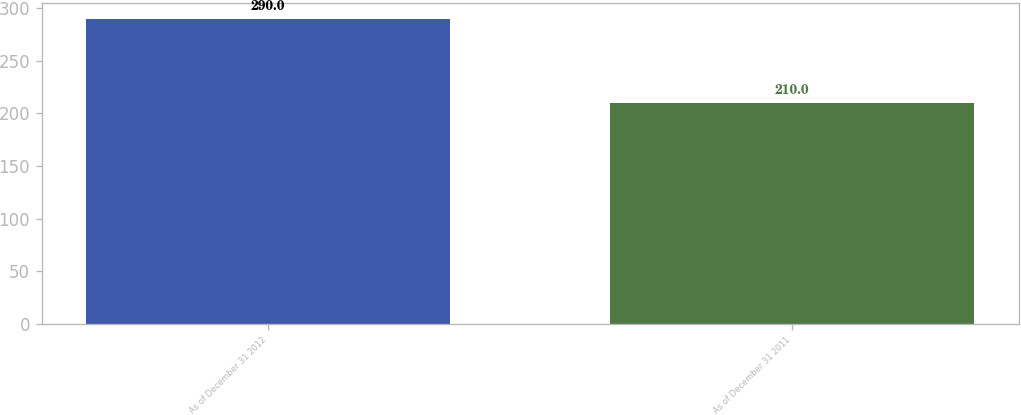Convert chart. <chart><loc_0><loc_0><loc_500><loc_500><bar_chart><fcel>As of December 31 2012<fcel>As of December 31 2011<nl><fcel>290<fcel>210<nl></chart> 